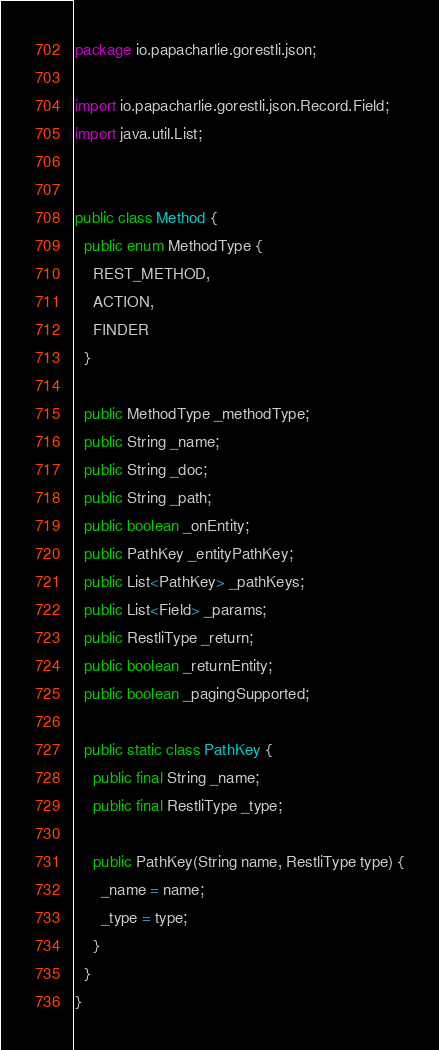Convert code to text. <code><loc_0><loc_0><loc_500><loc_500><_Java_>package io.papacharlie.gorestli.json;

import io.papacharlie.gorestli.json.Record.Field;
import java.util.List;


public class Method {
  public enum MethodType {
    REST_METHOD,
    ACTION,
    FINDER
  }

  public MethodType _methodType;
  public String _name;
  public String _doc;
  public String _path;
  public boolean _onEntity;
  public PathKey _entityPathKey;
  public List<PathKey> _pathKeys;
  public List<Field> _params;
  public RestliType _return;
  public boolean _returnEntity;
  public boolean _pagingSupported;

  public static class PathKey {
    public final String _name;
    public final RestliType _type;

    public PathKey(String name, RestliType type) {
      _name = name;
      _type = type;
    }
  }
}
</code> 